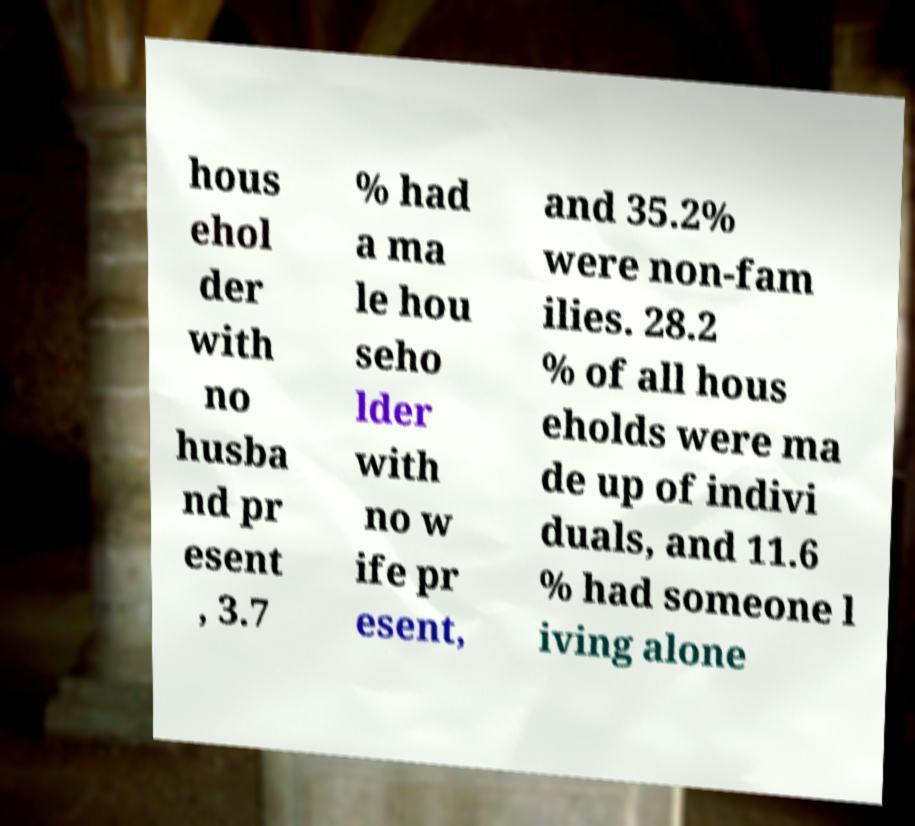Could you extract and type out the text from this image? hous ehol der with no husba nd pr esent , 3.7 % had a ma le hou seho lder with no w ife pr esent, and 35.2% were non-fam ilies. 28.2 % of all hous eholds were ma de up of indivi duals, and 11.6 % had someone l iving alone 